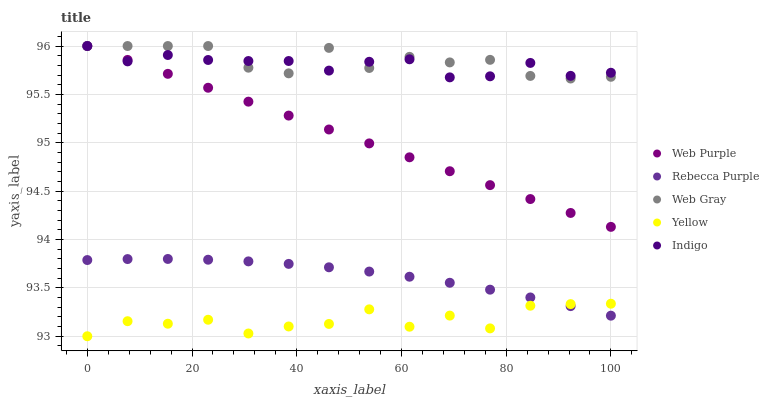Does Yellow have the minimum area under the curve?
Answer yes or no. Yes. Does Web Gray have the maximum area under the curve?
Answer yes or no. Yes. Does Indigo have the minimum area under the curve?
Answer yes or no. No. Does Indigo have the maximum area under the curve?
Answer yes or no. No. Is Web Purple the smoothest?
Answer yes or no. Yes. Is Yellow the roughest?
Answer yes or no. Yes. Is Web Gray the smoothest?
Answer yes or no. No. Is Web Gray the roughest?
Answer yes or no. No. Does Yellow have the lowest value?
Answer yes or no. Yes. Does Web Gray have the lowest value?
Answer yes or no. No. Does Indigo have the highest value?
Answer yes or no. Yes. Does Rebecca Purple have the highest value?
Answer yes or no. No. Is Yellow less than Web Purple?
Answer yes or no. Yes. Is Web Gray greater than Rebecca Purple?
Answer yes or no. Yes. Does Web Purple intersect Web Gray?
Answer yes or no. Yes. Is Web Purple less than Web Gray?
Answer yes or no. No. Is Web Purple greater than Web Gray?
Answer yes or no. No. Does Yellow intersect Web Purple?
Answer yes or no. No. 